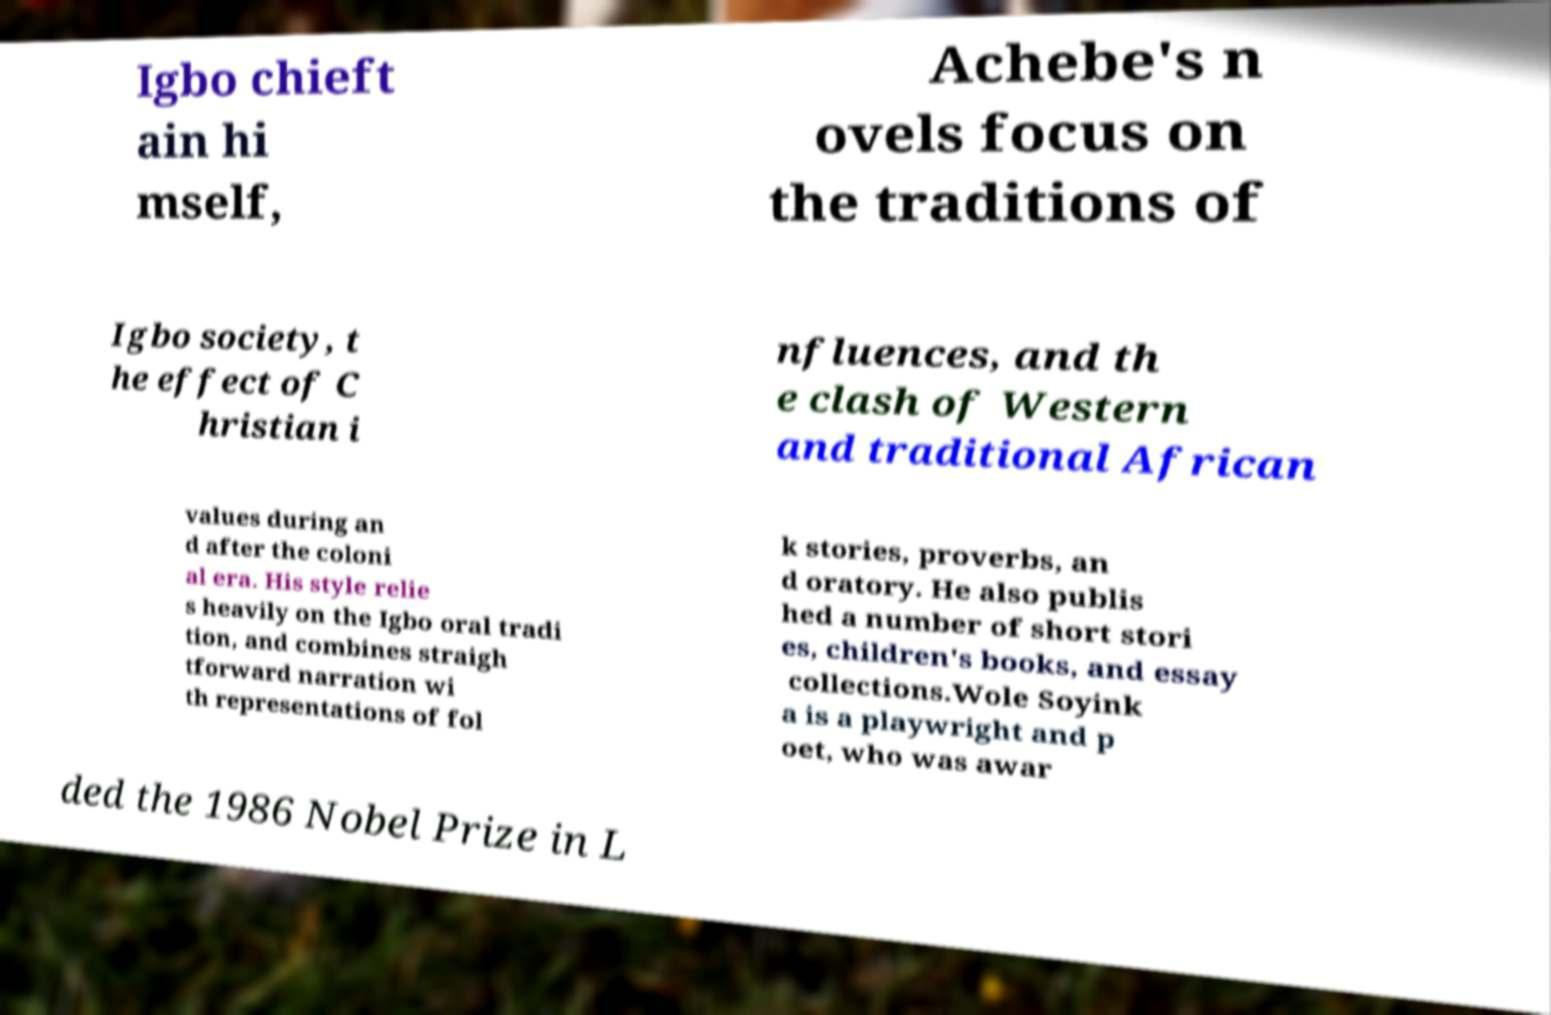Can you read and provide the text displayed in the image?This photo seems to have some interesting text. Can you extract and type it out for me? Igbo chieft ain hi mself, Achebe's n ovels focus on the traditions of Igbo society, t he effect of C hristian i nfluences, and th e clash of Western and traditional African values during an d after the coloni al era. His style relie s heavily on the Igbo oral tradi tion, and combines straigh tforward narration wi th representations of fol k stories, proverbs, an d oratory. He also publis hed a number of short stori es, children's books, and essay collections.Wole Soyink a is a playwright and p oet, who was awar ded the 1986 Nobel Prize in L 